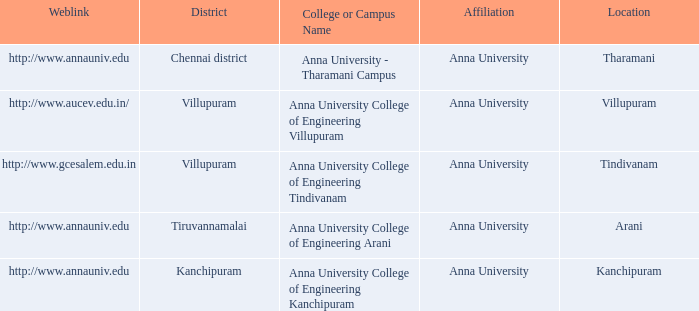What District has a Location of tharamani? Chennai district. 